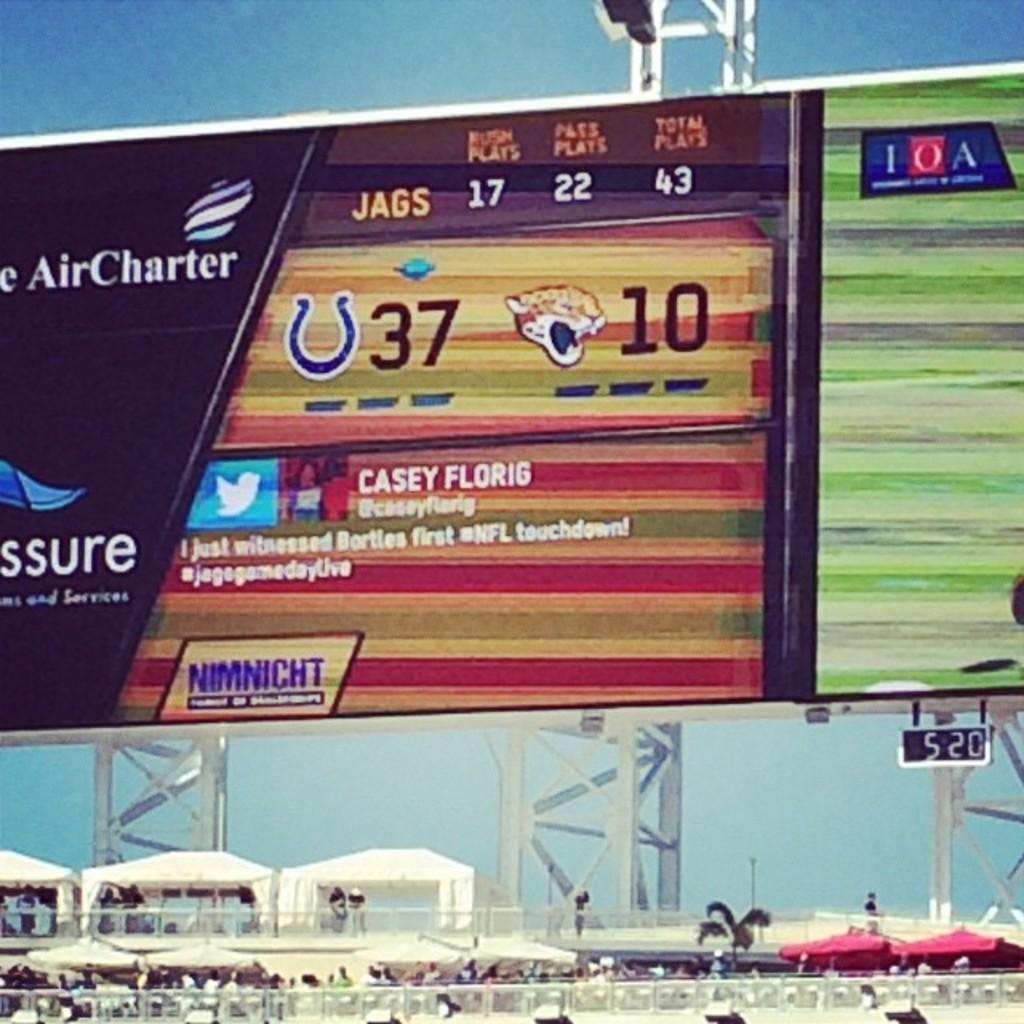<image>
Give a short and clear explanation of the subsequent image. The Jags are losing  to the Colts by a score of 37 to 10. 